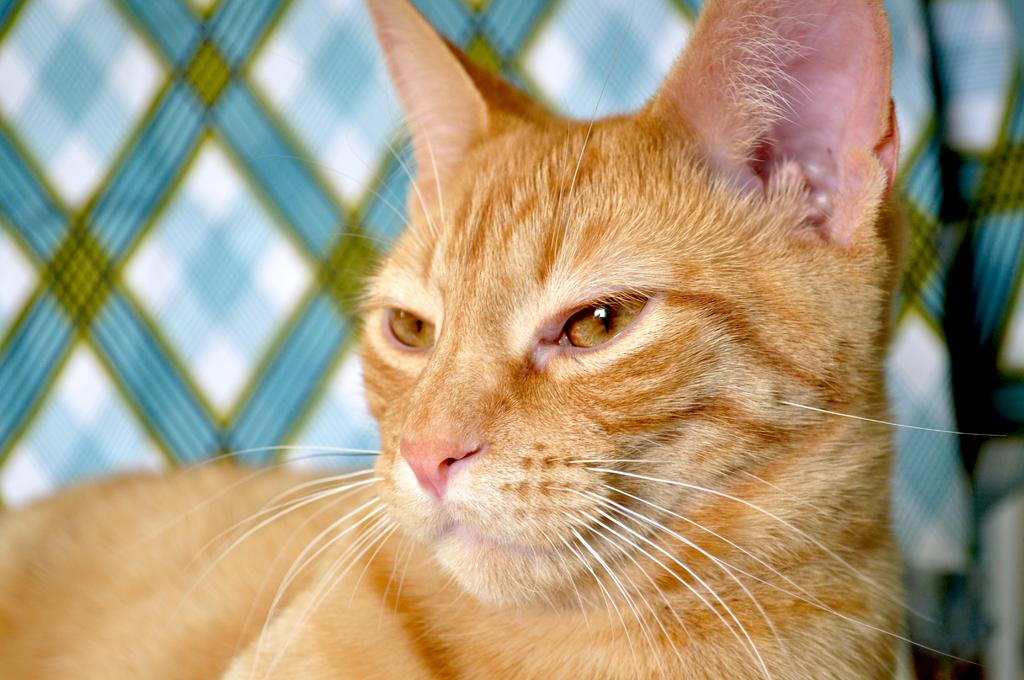What animal is present in the image? There is a cat in the picture. Can you describe the background of the image? The background of the image might include cloth or a couch. What type of yak can be seen in the image? There is no yak present in the image; it features a cat. How does the love between the cat and the yak manifest in the image? There is no love between the cat and a yak depicted in the image, as there is no yak present. 